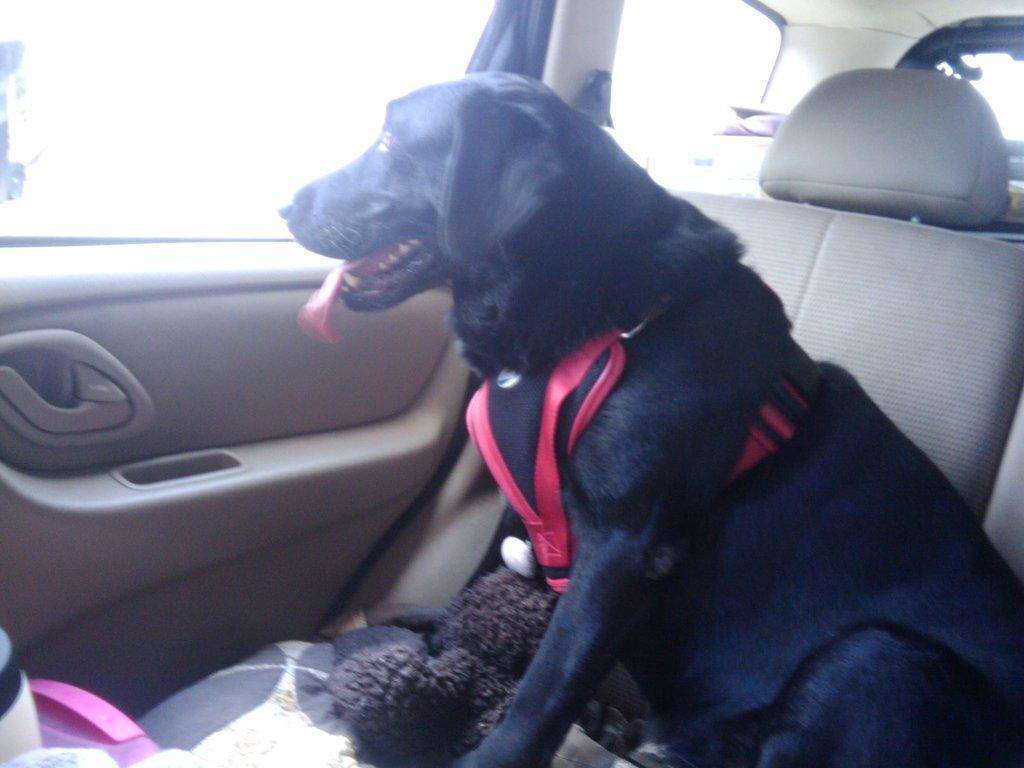In one or two sentences, can you explain what this image depicts? There is a black dog and a red belt is attached to it sitting in the car and looking through the window. 